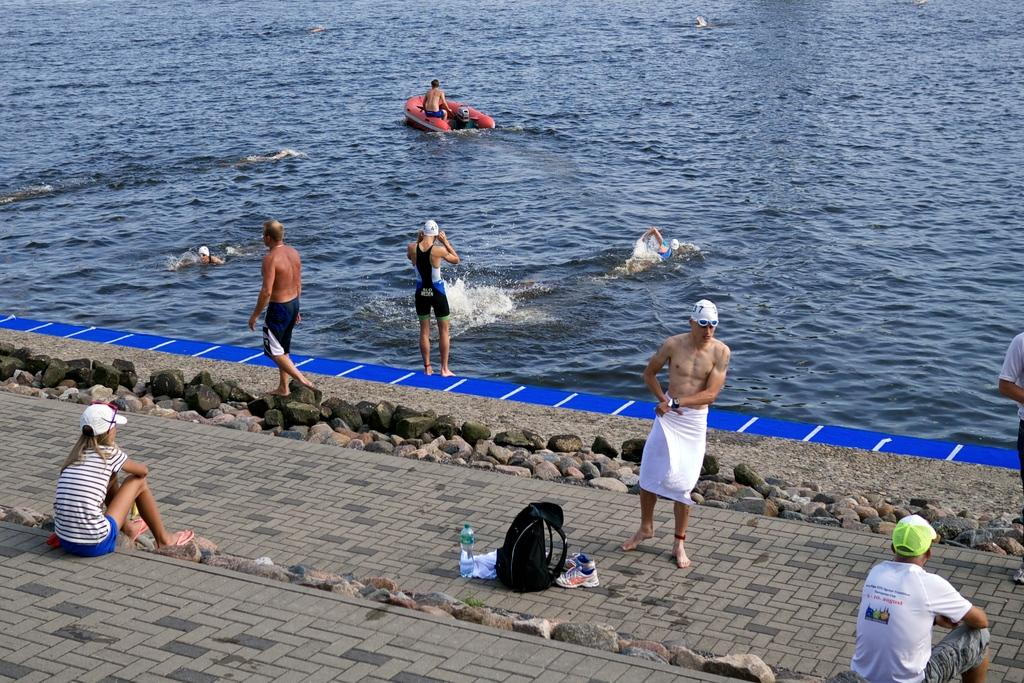What are the persons in the image wearing? The persons in the image are wearing clothes. What is the person on the boat doing? The person on the boat is floating on water. What other items can be seen in the image besides the boat and persons? There is a bag, shoes, and a bottle in the image. What type of chalk is being used to draw on the prison wall in the image? There is no chalk or prison wall present in the image. What act is the person on the boat performing in the image? The image does not show the person on the boat performing any specific act; they are simply floating on water. 